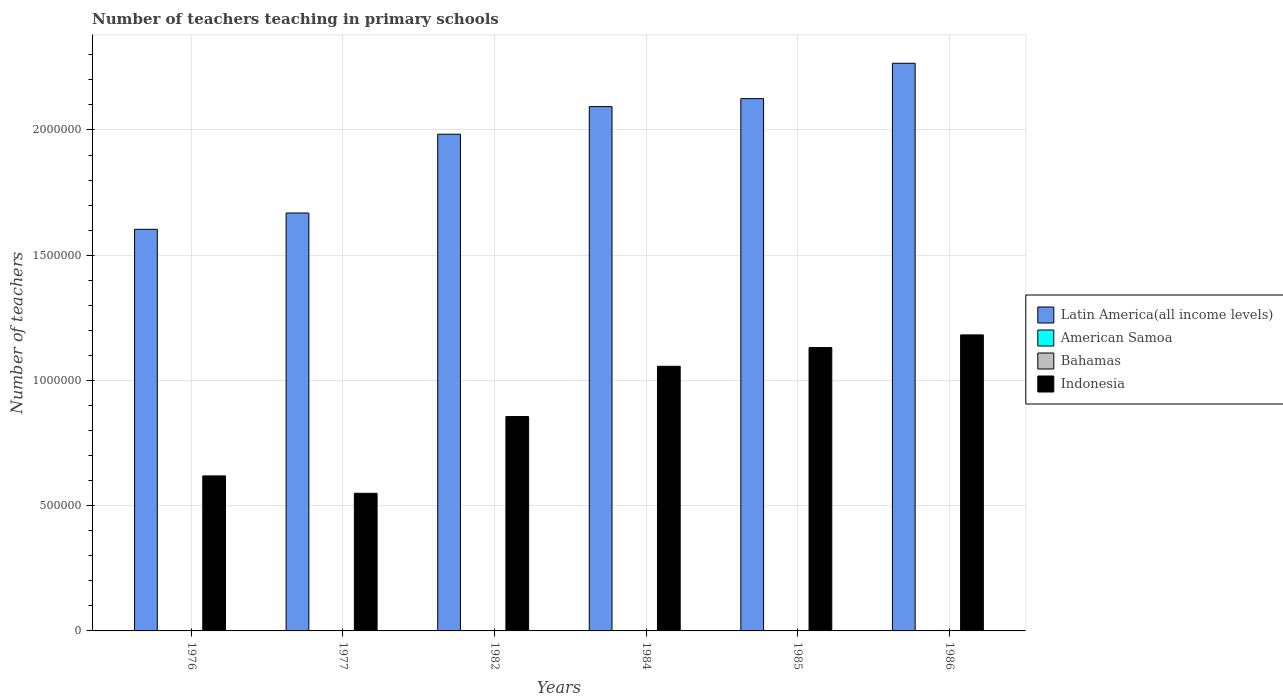How many groups of bars are there?
Offer a very short reply. 6. How many bars are there on the 6th tick from the left?
Provide a succinct answer. 4. What is the label of the 3rd group of bars from the left?
Offer a terse response. 1982. What is the number of teachers teaching in primary schools in Indonesia in 1986?
Give a very brief answer. 1.18e+06. Across all years, what is the maximum number of teachers teaching in primary schools in Indonesia?
Offer a very short reply. 1.18e+06. Across all years, what is the minimum number of teachers teaching in primary schools in Latin America(all income levels)?
Make the answer very short. 1.60e+06. In which year was the number of teachers teaching in primary schools in Latin America(all income levels) maximum?
Give a very brief answer. 1986. What is the total number of teachers teaching in primary schools in Bahamas in the graph?
Give a very brief answer. 8755. What is the difference between the number of teachers teaching in primary schools in Bahamas in 1976 and that in 1977?
Provide a short and direct response. -123. What is the difference between the number of teachers teaching in primary schools in Indonesia in 1977 and the number of teachers teaching in primary schools in American Samoa in 1985?
Make the answer very short. 5.49e+05. What is the average number of teachers teaching in primary schools in Indonesia per year?
Make the answer very short. 8.99e+05. In the year 1984, what is the difference between the number of teachers teaching in primary schools in American Samoa and number of teachers teaching in primary schools in Latin America(all income levels)?
Provide a succinct answer. -2.09e+06. In how many years, is the number of teachers teaching in primary schools in American Samoa greater than 300000?
Your answer should be very brief. 0. What is the ratio of the number of teachers teaching in primary schools in Latin America(all income levels) in 1976 to that in 1986?
Offer a terse response. 0.71. Is the number of teachers teaching in primary schools in American Samoa in 1976 less than that in 1985?
Your answer should be compact. Yes. Is the difference between the number of teachers teaching in primary schools in American Samoa in 1982 and 1986 greater than the difference between the number of teachers teaching in primary schools in Latin America(all income levels) in 1982 and 1986?
Offer a very short reply. Yes. What is the difference between the highest and the second highest number of teachers teaching in primary schools in Latin America(all income levels)?
Your answer should be compact. 1.41e+05. What is the difference between the highest and the lowest number of teachers teaching in primary schools in Indonesia?
Ensure brevity in your answer.  6.32e+05. In how many years, is the number of teachers teaching in primary schools in Latin America(all income levels) greater than the average number of teachers teaching in primary schools in Latin America(all income levels) taken over all years?
Ensure brevity in your answer.  4. Is the sum of the number of teachers teaching in primary schools in American Samoa in 1982 and 1984 greater than the maximum number of teachers teaching in primary schools in Indonesia across all years?
Provide a succinct answer. No. Is it the case that in every year, the sum of the number of teachers teaching in primary schools in Indonesia and number of teachers teaching in primary schools in American Samoa is greater than the sum of number of teachers teaching in primary schools in Bahamas and number of teachers teaching in primary schools in Latin America(all income levels)?
Give a very brief answer. No. What does the 2nd bar from the left in 1984 represents?
Provide a succinct answer. American Samoa. What does the 3rd bar from the right in 1986 represents?
Ensure brevity in your answer.  American Samoa. How many bars are there?
Offer a terse response. 24. Are all the bars in the graph horizontal?
Offer a terse response. No. How many years are there in the graph?
Keep it short and to the point. 6. Are the values on the major ticks of Y-axis written in scientific E-notation?
Offer a very short reply. No. Does the graph contain any zero values?
Keep it short and to the point. No. Does the graph contain grids?
Give a very brief answer. Yes. Where does the legend appear in the graph?
Keep it short and to the point. Center right. How many legend labels are there?
Offer a very short reply. 4. How are the legend labels stacked?
Make the answer very short. Vertical. What is the title of the graph?
Offer a terse response. Number of teachers teaching in primary schools. What is the label or title of the X-axis?
Give a very brief answer. Years. What is the label or title of the Y-axis?
Provide a short and direct response. Number of teachers. What is the Number of teachers of Latin America(all income levels) in 1976?
Offer a very short reply. 1.60e+06. What is the Number of teachers of American Samoa in 1976?
Give a very brief answer. 302. What is the Number of teachers in Bahamas in 1976?
Provide a succinct answer. 1294. What is the Number of teachers of Indonesia in 1976?
Give a very brief answer. 6.19e+05. What is the Number of teachers of Latin America(all income levels) in 1977?
Provide a succinct answer. 1.67e+06. What is the Number of teachers of American Samoa in 1977?
Offer a terse response. 310. What is the Number of teachers in Bahamas in 1977?
Offer a terse response. 1417. What is the Number of teachers of Indonesia in 1977?
Your response must be concise. 5.50e+05. What is the Number of teachers in Latin America(all income levels) in 1982?
Your answer should be compact. 1.98e+06. What is the Number of teachers in American Samoa in 1982?
Ensure brevity in your answer.  395. What is the Number of teachers in Bahamas in 1982?
Ensure brevity in your answer.  1151. What is the Number of teachers of Indonesia in 1982?
Offer a terse response. 8.56e+05. What is the Number of teachers of Latin America(all income levels) in 1984?
Offer a terse response. 2.09e+06. What is the Number of teachers of American Samoa in 1984?
Your response must be concise. 346. What is the Number of teachers of Bahamas in 1984?
Your response must be concise. 1565. What is the Number of teachers in Indonesia in 1984?
Ensure brevity in your answer.  1.06e+06. What is the Number of teachers in Latin America(all income levels) in 1985?
Your answer should be very brief. 2.13e+06. What is the Number of teachers of American Samoa in 1985?
Provide a succinct answer. 359. What is the Number of teachers in Bahamas in 1985?
Provide a succinct answer. 1561. What is the Number of teachers in Indonesia in 1985?
Your answer should be very brief. 1.13e+06. What is the Number of teachers in Latin America(all income levels) in 1986?
Make the answer very short. 2.27e+06. What is the Number of teachers of American Samoa in 1986?
Give a very brief answer. 454. What is the Number of teachers of Bahamas in 1986?
Keep it short and to the point. 1767. What is the Number of teachers in Indonesia in 1986?
Provide a succinct answer. 1.18e+06. Across all years, what is the maximum Number of teachers in Latin America(all income levels)?
Offer a very short reply. 2.27e+06. Across all years, what is the maximum Number of teachers of American Samoa?
Make the answer very short. 454. Across all years, what is the maximum Number of teachers in Bahamas?
Keep it short and to the point. 1767. Across all years, what is the maximum Number of teachers in Indonesia?
Offer a very short reply. 1.18e+06. Across all years, what is the minimum Number of teachers of Latin America(all income levels)?
Your answer should be very brief. 1.60e+06. Across all years, what is the minimum Number of teachers of American Samoa?
Your answer should be very brief. 302. Across all years, what is the minimum Number of teachers of Bahamas?
Make the answer very short. 1151. Across all years, what is the minimum Number of teachers of Indonesia?
Your response must be concise. 5.50e+05. What is the total Number of teachers in Latin America(all income levels) in the graph?
Offer a very short reply. 1.17e+07. What is the total Number of teachers in American Samoa in the graph?
Ensure brevity in your answer.  2166. What is the total Number of teachers in Bahamas in the graph?
Offer a terse response. 8755. What is the total Number of teachers in Indonesia in the graph?
Your answer should be very brief. 5.39e+06. What is the difference between the Number of teachers in Latin America(all income levels) in 1976 and that in 1977?
Your response must be concise. -6.51e+04. What is the difference between the Number of teachers in American Samoa in 1976 and that in 1977?
Give a very brief answer. -8. What is the difference between the Number of teachers of Bahamas in 1976 and that in 1977?
Provide a succinct answer. -123. What is the difference between the Number of teachers in Indonesia in 1976 and that in 1977?
Offer a very short reply. 6.93e+04. What is the difference between the Number of teachers of Latin America(all income levels) in 1976 and that in 1982?
Offer a very short reply. -3.80e+05. What is the difference between the Number of teachers of American Samoa in 1976 and that in 1982?
Your answer should be compact. -93. What is the difference between the Number of teachers of Bahamas in 1976 and that in 1982?
Ensure brevity in your answer.  143. What is the difference between the Number of teachers of Indonesia in 1976 and that in 1982?
Offer a very short reply. -2.37e+05. What is the difference between the Number of teachers in Latin America(all income levels) in 1976 and that in 1984?
Give a very brief answer. -4.90e+05. What is the difference between the Number of teachers in American Samoa in 1976 and that in 1984?
Provide a short and direct response. -44. What is the difference between the Number of teachers of Bahamas in 1976 and that in 1984?
Give a very brief answer. -271. What is the difference between the Number of teachers in Indonesia in 1976 and that in 1984?
Keep it short and to the point. -4.38e+05. What is the difference between the Number of teachers of Latin America(all income levels) in 1976 and that in 1985?
Give a very brief answer. -5.22e+05. What is the difference between the Number of teachers in American Samoa in 1976 and that in 1985?
Your answer should be very brief. -57. What is the difference between the Number of teachers of Bahamas in 1976 and that in 1985?
Ensure brevity in your answer.  -267. What is the difference between the Number of teachers in Indonesia in 1976 and that in 1985?
Give a very brief answer. -5.12e+05. What is the difference between the Number of teachers of Latin America(all income levels) in 1976 and that in 1986?
Keep it short and to the point. -6.63e+05. What is the difference between the Number of teachers of American Samoa in 1976 and that in 1986?
Ensure brevity in your answer.  -152. What is the difference between the Number of teachers in Bahamas in 1976 and that in 1986?
Make the answer very short. -473. What is the difference between the Number of teachers in Indonesia in 1976 and that in 1986?
Provide a short and direct response. -5.63e+05. What is the difference between the Number of teachers in Latin America(all income levels) in 1977 and that in 1982?
Your answer should be compact. -3.15e+05. What is the difference between the Number of teachers of American Samoa in 1977 and that in 1982?
Offer a terse response. -85. What is the difference between the Number of teachers of Bahamas in 1977 and that in 1982?
Keep it short and to the point. 266. What is the difference between the Number of teachers of Indonesia in 1977 and that in 1982?
Provide a short and direct response. -3.06e+05. What is the difference between the Number of teachers in Latin America(all income levels) in 1977 and that in 1984?
Ensure brevity in your answer.  -4.25e+05. What is the difference between the Number of teachers of American Samoa in 1977 and that in 1984?
Keep it short and to the point. -36. What is the difference between the Number of teachers of Bahamas in 1977 and that in 1984?
Ensure brevity in your answer.  -148. What is the difference between the Number of teachers in Indonesia in 1977 and that in 1984?
Provide a succinct answer. -5.07e+05. What is the difference between the Number of teachers in Latin America(all income levels) in 1977 and that in 1985?
Give a very brief answer. -4.57e+05. What is the difference between the Number of teachers of American Samoa in 1977 and that in 1985?
Provide a short and direct response. -49. What is the difference between the Number of teachers of Bahamas in 1977 and that in 1985?
Ensure brevity in your answer.  -144. What is the difference between the Number of teachers of Indonesia in 1977 and that in 1985?
Provide a succinct answer. -5.82e+05. What is the difference between the Number of teachers of Latin America(all income levels) in 1977 and that in 1986?
Ensure brevity in your answer.  -5.98e+05. What is the difference between the Number of teachers in American Samoa in 1977 and that in 1986?
Offer a very short reply. -144. What is the difference between the Number of teachers in Bahamas in 1977 and that in 1986?
Offer a terse response. -350. What is the difference between the Number of teachers in Indonesia in 1977 and that in 1986?
Ensure brevity in your answer.  -6.32e+05. What is the difference between the Number of teachers of Latin America(all income levels) in 1982 and that in 1984?
Offer a terse response. -1.10e+05. What is the difference between the Number of teachers of Bahamas in 1982 and that in 1984?
Offer a very short reply. -414. What is the difference between the Number of teachers of Indonesia in 1982 and that in 1984?
Offer a very short reply. -2.01e+05. What is the difference between the Number of teachers of Latin America(all income levels) in 1982 and that in 1985?
Provide a succinct answer. -1.42e+05. What is the difference between the Number of teachers of Bahamas in 1982 and that in 1985?
Give a very brief answer. -410. What is the difference between the Number of teachers in Indonesia in 1982 and that in 1985?
Provide a succinct answer. -2.75e+05. What is the difference between the Number of teachers of Latin America(all income levels) in 1982 and that in 1986?
Offer a very short reply. -2.83e+05. What is the difference between the Number of teachers in American Samoa in 1982 and that in 1986?
Keep it short and to the point. -59. What is the difference between the Number of teachers in Bahamas in 1982 and that in 1986?
Offer a terse response. -616. What is the difference between the Number of teachers of Indonesia in 1982 and that in 1986?
Offer a very short reply. -3.26e+05. What is the difference between the Number of teachers in Latin America(all income levels) in 1984 and that in 1985?
Offer a terse response. -3.20e+04. What is the difference between the Number of teachers in American Samoa in 1984 and that in 1985?
Offer a very short reply. -13. What is the difference between the Number of teachers of Indonesia in 1984 and that in 1985?
Provide a succinct answer. -7.48e+04. What is the difference between the Number of teachers in Latin America(all income levels) in 1984 and that in 1986?
Provide a short and direct response. -1.73e+05. What is the difference between the Number of teachers in American Samoa in 1984 and that in 1986?
Give a very brief answer. -108. What is the difference between the Number of teachers in Bahamas in 1984 and that in 1986?
Make the answer very short. -202. What is the difference between the Number of teachers of Indonesia in 1984 and that in 1986?
Your response must be concise. -1.25e+05. What is the difference between the Number of teachers of Latin America(all income levels) in 1985 and that in 1986?
Keep it short and to the point. -1.41e+05. What is the difference between the Number of teachers of American Samoa in 1985 and that in 1986?
Your answer should be very brief. -95. What is the difference between the Number of teachers in Bahamas in 1985 and that in 1986?
Your response must be concise. -206. What is the difference between the Number of teachers in Indonesia in 1985 and that in 1986?
Provide a short and direct response. -5.05e+04. What is the difference between the Number of teachers in Latin America(all income levels) in 1976 and the Number of teachers in American Samoa in 1977?
Ensure brevity in your answer.  1.60e+06. What is the difference between the Number of teachers of Latin America(all income levels) in 1976 and the Number of teachers of Bahamas in 1977?
Make the answer very short. 1.60e+06. What is the difference between the Number of teachers in Latin America(all income levels) in 1976 and the Number of teachers in Indonesia in 1977?
Make the answer very short. 1.05e+06. What is the difference between the Number of teachers of American Samoa in 1976 and the Number of teachers of Bahamas in 1977?
Give a very brief answer. -1115. What is the difference between the Number of teachers of American Samoa in 1976 and the Number of teachers of Indonesia in 1977?
Offer a very short reply. -5.49e+05. What is the difference between the Number of teachers of Bahamas in 1976 and the Number of teachers of Indonesia in 1977?
Your response must be concise. -5.48e+05. What is the difference between the Number of teachers in Latin America(all income levels) in 1976 and the Number of teachers in American Samoa in 1982?
Make the answer very short. 1.60e+06. What is the difference between the Number of teachers in Latin America(all income levels) in 1976 and the Number of teachers in Bahamas in 1982?
Make the answer very short. 1.60e+06. What is the difference between the Number of teachers in Latin America(all income levels) in 1976 and the Number of teachers in Indonesia in 1982?
Ensure brevity in your answer.  7.47e+05. What is the difference between the Number of teachers of American Samoa in 1976 and the Number of teachers of Bahamas in 1982?
Your response must be concise. -849. What is the difference between the Number of teachers in American Samoa in 1976 and the Number of teachers in Indonesia in 1982?
Your answer should be very brief. -8.56e+05. What is the difference between the Number of teachers in Bahamas in 1976 and the Number of teachers in Indonesia in 1982?
Your response must be concise. -8.55e+05. What is the difference between the Number of teachers of Latin America(all income levels) in 1976 and the Number of teachers of American Samoa in 1984?
Offer a terse response. 1.60e+06. What is the difference between the Number of teachers of Latin America(all income levels) in 1976 and the Number of teachers of Bahamas in 1984?
Offer a terse response. 1.60e+06. What is the difference between the Number of teachers in Latin America(all income levels) in 1976 and the Number of teachers in Indonesia in 1984?
Your response must be concise. 5.47e+05. What is the difference between the Number of teachers in American Samoa in 1976 and the Number of teachers in Bahamas in 1984?
Make the answer very short. -1263. What is the difference between the Number of teachers in American Samoa in 1976 and the Number of teachers in Indonesia in 1984?
Your answer should be compact. -1.06e+06. What is the difference between the Number of teachers in Bahamas in 1976 and the Number of teachers in Indonesia in 1984?
Give a very brief answer. -1.06e+06. What is the difference between the Number of teachers in Latin America(all income levels) in 1976 and the Number of teachers in American Samoa in 1985?
Offer a terse response. 1.60e+06. What is the difference between the Number of teachers of Latin America(all income levels) in 1976 and the Number of teachers of Bahamas in 1985?
Your answer should be very brief. 1.60e+06. What is the difference between the Number of teachers in Latin America(all income levels) in 1976 and the Number of teachers in Indonesia in 1985?
Provide a short and direct response. 4.72e+05. What is the difference between the Number of teachers in American Samoa in 1976 and the Number of teachers in Bahamas in 1985?
Your answer should be very brief. -1259. What is the difference between the Number of teachers of American Samoa in 1976 and the Number of teachers of Indonesia in 1985?
Provide a succinct answer. -1.13e+06. What is the difference between the Number of teachers in Bahamas in 1976 and the Number of teachers in Indonesia in 1985?
Ensure brevity in your answer.  -1.13e+06. What is the difference between the Number of teachers of Latin America(all income levels) in 1976 and the Number of teachers of American Samoa in 1986?
Give a very brief answer. 1.60e+06. What is the difference between the Number of teachers of Latin America(all income levels) in 1976 and the Number of teachers of Bahamas in 1986?
Your response must be concise. 1.60e+06. What is the difference between the Number of teachers in Latin America(all income levels) in 1976 and the Number of teachers in Indonesia in 1986?
Provide a short and direct response. 4.22e+05. What is the difference between the Number of teachers in American Samoa in 1976 and the Number of teachers in Bahamas in 1986?
Provide a succinct answer. -1465. What is the difference between the Number of teachers of American Samoa in 1976 and the Number of teachers of Indonesia in 1986?
Your answer should be very brief. -1.18e+06. What is the difference between the Number of teachers of Bahamas in 1976 and the Number of teachers of Indonesia in 1986?
Your answer should be very brief. -1.18e+06. What is the difference between the Number of teachers in Latin America(all income levels) in 1977 and the Number of teachers in American Samoa in 1982?
Your response must be concise. 1.67e+06. What is the difference between the Number of teachers of Latin America(all income levels) in 1977 and the Number of teachers of Bahamas in 1982?
Your response must be concise. 1.67e+06. What is the difference between the Number of teachers in Latin America(all income levels) in 1977 and the Number of teachers in Indonesia in 1982?
Provide a short and direct response. 8.13e+05. What is the difference between the Number of teachers of American Samoa in 1977 and the Number of teachers of Bahamas in 1982?
Ensure brevity in your answer.  -841. What is the difference between the Number of teachers in American Samoa in 1977 and the Number of teachers in Indonesia in 1982?
Give a very brief answer. -8.56e+05. What is the difference between the Number of teachers of Bahamas in 1977 and the Number of teachers of Indonesia in 1982?
Provide a short and direct response. -8.54e+05. What is the difference between the Number of teachers in Latin America(all income levels) in 1977 and the Number of teachers in American Samoa in 1984?
Provide a short and direct response. 1.67e+06. What is the difference between the Number of teachers of Latin America(all income levels) in 1977 and the Number of teachers of Bahamas in 1984?
Your answer should be very brief. 1.67e+06. What is the difference between the Number of teachers in Latin America(all income levels) in 1977 and the Number of teachers in Indonesia in 1984?
Your response must be concise. 6.12e+05. What is the difference between the Number of teachers in American Samoa in 1977 and the Number of teachers in Bahamas in 1984?
Offer a very short reply. -1255. What is the difference between the Number of teachers in American Samoa in 1977 and the Number of teachers in Indonesia in 1984?
Keep it short and to the point. -1.06e+06. What is the difference between the Number of teachers in Bahamas in 1977 and the Number of teachers in Indonesia in 1984?
Offer a terse response. -1.06e+06. What is the difference between the Number of teachers in Latin America(all income levels) in 1977 and the Number of teachers in American Samoa in 1985?
Provide a short and direct response. 1.67e+06. What is the difference between the Number of teachers in Latin America(all income levels) in 1977 and the Number of teachers in Bahamas in 1985?
Your answer should be compact. 1.67e+06. What is the difference between the Number of teachers of Latin America(all income levels) in 1977 and the Number of teachers of Indonesia in 1985?
Keep it short and to the point. 5.37e+05. What is the difference between the Number of teachers of American Samoa in 1977 and the Number of teachers of Bahamas in 1985?
Keep it short and to the point. -1251. What is the difference between the Number of teachers in American Samoa in 1977 and the Number of teachers in Indonesia in 1985?
Make the answer very short. -1.13e+06. What is the difference between the Number of teachers in Bahamas in 1977 and the Number of teachers in Indonesia in 1985?
Your answer should be compact. -1.13e+06. What is the difference between the Number of teachers of Latin America(all income levels) in 1977 and the Number of teachers of American Samoa in 1986?
Your answer should be compact. 1.67e+06. What is the difference between the Number of teachers of Latin America(all income levels) in 1977 and the Number of teachers of Bahamas in 1986?
Offer a very short reply. 1.67e+06. What is the difference between the Number of teachers of Latin America(all income levels) in 1977 and the Number of teachers of Indonesia in 1986?
Your answer should be compact. 4.87e+05. What is the difference between the Number of teachers in American Samoa in 1977 and the Number of teachers in Bahamas in 1986?
Ensure brevity in your answer.  -1457. What is the difference between the Number of teachers in American Samoa in 1977 and the Number of teachers in Indonesia in 1986?
Provide a short and direct response. -1.18e+06. What is the difference between the Number of teachers in Bahamas in 1977 and the Number of teachers in Indonesia in 1986?
Ensure brevity in your answer.  -1.18e+06. What is the difference between the Number of teachers in Latin America(all income levels) in 1982 and the Number of teachers in American Samoa in 1984?
Your answer should be compact. 1.98e+06. What is the difference between the Number of teachers of Latin America(all income levels) in 1982 and the Number of teachers of Bahamas in 1984?
Offer a very short reply. 1.98e+06. What is the difference between the Number of teachers of Latin America(all income levels) in 1982 and the Number of teachers of Indonesia in 1984?
Provide a short and direct response. 9.27e+05. What is the difference between the Number of teachers of American Samoa in 1982 and the Number of teachers of Bahamas in 1984?
Provide a short and direct response. -1170. What is the difference between the Number of teachers of American Samoa in 1982 and the Number of teachers of Indonesia in 1984?
Your answer should be very brief. -1.06e+06. What is the difference between the Number of teachers in Bahamas in 1982 and the Number of teachers in Indonesia in 1984?
Give a very brief answer. -1.06e+06. What is the difference between the Number of teachers of Latin America(all income levels) in 1982 and the Number of teachers of American Samoa in 1985?
Offer a terse response. 1.98e+06. What is the difference between the Number of teachers of Latin America(all income levels) in 1982 and the Number of teachers of Bahamas in 1985?
Ensure brevity in your answer.  1.98e+06. What is the difference between the Number of teachers in Latin America(all income levels) in 1982 and the Number of teachers in Indonesia in 1985?
Offer a very short reply. 8.52e+05. What is the difference between the Number of teachers of American Samoa in 1982 and the Number of teachers of Bahamas in 1985?
Keep it short and to the point. -1166. What is the difference between the Number of teachers in American Samoa in 1982 and the Number of teachers in Indonesia in 1985?
Your answer should be compact. -1.13e+06. What is the difference between the Number of teachers in Bahamas in 1982 and the Number of teachers in Indonesia in 1985?
Keep it short and to the point. -1.13e+06. What is the difference between the Number of teachers of Latin America(all income levels) in 1982 and the Number of teachers of American Samoa in 1986?
Ensure brevity in your answer.  1.98e+06. What is the difference between the Number of teachers of Latin America(all income levels) in 1982 and the Number of teachers of Bahamas in 1986?
Ensure brevity in your answer.  1.98e+06. What is the difference between the Number of teachers of Latin America(all income levels) in 1982 and the Number of teachers of Indonesia in 1986?
Keep it short and to the point. 8.01e+05. What is the difference between the Number of teachers in American Samoa in 1982 and the Number of teachers in Bahamas in 1986?
Provide a succinct answer. -1372. What is the difference between the Number of teachers in American Samoa in 1982 and the Number of teachers in Indonesia in 1986?
Your answer should be compact. -1.18e+06. What is the difference between the Number of teachers of Bahamas in 1982 and the Number of teachers of Indonesia in 1986?
Provide a short and direct response. -1.18e+06. What is the difference between the Number of teachers in Latin America(all income levels) in 1984 and the Number of teachers in American Samoa in 1985?
Offer a very short reply. 2.09e+06. What is the difference between the Number of teachers in Latin America(all income levels) in 1984 and the Number of teachers in Bahamas in 1985?
Provide a short and direct response. 2.09e+06. What is the difference between the Number of teachers in Latin America(all income levels) in 1984 and the Number of teachers in Indonesia in 1985?
Offer a very short reply. 9.62e+05. What is the difference between the Number of teachers in American Samoa in 1984 and the Number of teachers in Bahamas in 1985?
Your answer should be compact. -1215. What is the difference between the Number of teachers of American Samoa in 1984 and the Number of teachers of Indonesia in 1985?
Offer a terse response. -1.13e+06. What is the difference between the Number of teachers in Bahamas in 1984 and the Number of teachers in Indonesia in 1985?
Ensure brevity in your answer.  -1.13e+06. What is the difference between the Number of teachers in Latin America(all income levels) in 1984 and the Number of teachers in American Samoa in 1986?
Your answer should be very brief. 2.09e+06. What is the difference between the Number of teachers in Latin America(all income levels) in 1984 and the Number of teachers in Bahamas in 1986?
Your answer should be compact. 2.09e+06. What is the difference between the Number of teachers in Latin America(all income levels) in 1984 and the Number of teachers in Indonesia in 1986?
Give a very brief answer. 9.11e+05. What is the difference between the Number of teachers of American Samoa in 1984 and the Number of teachers of Bahamas in 1986?
Ensure brevity in your answer.  -1421. What is the difference between the Number of teachers of American Samoa in 1984 and the Number of teachers of Indonesia in 1986?
Your answer should be compact. -1.18e+06. What is the difference between the Number of teachers in Bahamas in 1984 and the Number of teachers in Indonesia in 1986?
Give a very brief answer. -1.18e+06. What is the difference between the Number of teachers of Latin America(all income levels) in 1985 and the Number of teachers of American Samoa in 1986?
Provide a succinct answer. 2.12e+06. What is the difference between the Number of teachers of Latin America(all income levels) in 1985 and the Number of teachers of Bahamas in 1986?
Offer a terse response. 2.12e+06. What is the difference between the Number of teachers of Latin America(all income levels) in 1985 and the Number of teachers of Indonesia in 1986?
Give a very brief answer. 9.43e+05. What is the difference between the Number of teachers of American Samoa in 1985 and the Number of teachers of Bahamas in 1986?
Your answer should be compact. -1408. What is the difference between the Number of teachers of American Samoa in 1985 and the Number of teachers of Indonesia in 1986?
Provide a succinct answer. -1.18e+06. What is the difference between the Number of teachers in Bahamas in 1985 and the Number of teachers in Indonesia in 1986?
Provide a short and direct response. -1.18e+06. What is the average Number of teachers of Latin America(all income levels) per year?
Offer a terse response. 1.96e+06. What is the average Number of teachers in American Samoa per year?
Give a very brief answer. 361. What is the average Number of teachers in Bahamas per year?
Your answer should be very brief. 1459.17. What is the average Number of teachers in Indonesia per year?
Provide a short and direct response. 8.99e+05. In the year 1976, what is the difference between the Number of teachers of Latin America(all income levels) and Number of teachers of American Samoa?
Your answer should be very brief. 1.60e+06. In the year 1976, what is the difference between the Number of teachers of Latin America(all income levels) and Number of teachers of Bahamas?
Your answer should be very brief. 1.60e+06. In the year 1976, what is the difference between the Number of teachers in Latin America(all income levels) and Number of teachers in Indonesia?
Your response must be concise. 9.85e+05. In the year 1976, what is the difference between the Number of teachers of American Samoa and Number of teachers of Bahamas?
Your answer should be very brief. -992. In the year 1976, what is the difference between the Number of teachers of American Samoa and Number of teachers of Indonesia?
Your response must be concise. -6.19e+05. In the year 1976, what is the difference between the Number of teachers in Bahamas and Number of teachers in Indonesia?
Your answer should be compact. -6.18e+05. In the year 1977, what is the difference between the Number of teachers in Latin America(all income levels) and Number of teachers in American Samoa?
Provide a short and direct response. 1.67e+06. In the year 1977, what is the difference between the Number of teachers of Latin America(all income levels) and Number of teachers of Bahamas?
Offer a terse response. 1.67e+06. In the year 1977, what is the difference between the Number of teachers of Latin America(all income levels) and Number of teachers of Indonesia?
Your response must be concise. 1.12e+06. In the year 1977, what is the difference between the Number of teachers in American Samoa and Number of teachers in Bahamas?
Your response must be concise. -1107. In the year 1977, what is the difference between the Number of teachers in American Samoa and Number of teachers in Indonesia?
Provide a succinct answer. -5.49e+05. In the year 1977, what is the difference between the Number of teachers in Bahamas and Number of teachers in Indonesia?
Your response must be concise. -5.48e+05. In the year 1982, what is the difference between the Number of teachers of Latin America(all income levels) and Number of teachers of American Samoa?
Give a very brief answer. 1.98e+06. In the year 1982, what is the difference between the Number of teachers in Latin America(all income levels) and Number of teachers in Bahamas?
Give a very brief answer. 1.98e+06. In the year 1982, what is the difference between the Number of teachers in Latin America(all income levels) and Number of teachers in Indonesia?
Keep it short and to the point. 1.13e+06. In the year 1982, what is the difference between the Number of teachers of American Samoa and Number of teachers of Bahamas?
Offer a terse response. -756. In the year 1982, what is the difference between the Number of teachers of American Samoa and Number of teachers of Indonesia?
Make the answer very short. -8.55e+05. In the year 1982, what is the difference between the Number of teachers in Bahamas and Number of teachers in Indonesia?
Your answer should be very brief. -8.55e+05. In the year 1984, what is the difference between the Number of teachers of Latin America(all income levels) and Number of teachers of American Samoa?
Give a very brief answer. 2.09e+06. In the year 1984, what is the difference between the Number of teachers in Latin America(all income levels) and Number of teachers in Bahamas?
Give a very brief answer. 2.09e+06. In the year 1984, what is the difference between the Number of teachers of Latin America(all income levels) and Number of teachers of Indonesia?
Offer a terse response. 1.04e+06. In the year 1984, what is the difference between the Number of teachers in American Samoa and Number of teachers in Bahamas?
Ensure brevity in your answer.  -1219. In the year 1984, what is the difference between the Number of teachers of American Samoa and Number of teachers of Indonesia?
Ensure brevity in your answer.  -1.06e+06. In the year 1984, what is the difference between the Number of teachers in Bahamas and Number of teachers in Indonesia?
Offer a very short reply. -1.05e+06. In the year 1985, what is the difference between the Number of teachers of Latin America(all income levels) and Number of teachers of American Samoa?
Provide a short and direct response. 2.12e+06. In the year 1985, what is the difference between the Number of teachers of Latin America(all income levels) and Number of teachers of Bahamas?
Give a very brief answer. 2.12e+06. In the year 1985, what is the difference between the Number of teachers of Latin America(all income levels) and Number of teachers of Indonesia?
Keep it short and to the point. 9.94e+05. In the year 1985, what is the difference between the Number of teachers in American Samoa and Number of teachers in Bahamas?
Provide a succinct answer. -1202. In the year 1985, what is the difference between the Number of teachers in American Samoa and Number of teachers in Indonesia?
Keep it short and to the point. -1.13e+06. In the year 1985, what is the difference between the Number of teachers in Bahamas and Number of teachers in Indonesia?
Make the answer very short. -1.13e+06. In the year 1986, what is the difference between the Number of teachers in Latin America(all income levels) and Number of teachers in American Samoa?
Provide a succinct answer. 2.27e+06. In the year 1986, what is the difference between the Number of teachers in Latin America(all income levels) and Number of teachers in Bahamas?
Your response must be concise. 2.26e+06. In the year 1986, what is the difference between the Number of teachers of Latin America(all income levels) and Number of teachers of Indonesia?
Ensure brevity in your answer.  1.08e+06. In the year 1986, what is the difference between the Number of teachers in American Samoa and Number of teachers in Bahamas?
Make the answer very short. -1313. In the year 1986, what is the difference between the Number of teachers of American Samoa and Number of teachers of Indonesia?
Ensure brevity in your answer.  -1.18e+06. In the year 1986, what is the difference between the Number of teachers in Bahamas and Number of teachers in Indonesia?
Ensure brevity in your answer.  -1.18e+06. What is the ratio of the Number of teachers of American Samoa in 1976 to that in 1977?
Keep it short and to the point. 0.97. What is the ratio of the Number of teachers in Bahamas in 1976 to that in 1977?
Give a very brief answer. 0.91. What is the ratio of the Number of teachers of Indonesia in 1976 to that in 1977?
Offer a very short reply. 1.13. What is the ratio of the Number of teachers of Latin America(all income levels) in 1976 to that in 1982?
Your answer should be compact. 0.81. What is the ratio of the Number of teachers of American Samoa in 1976 to that in 1982?
Provide a short and direct response. 0.76. What is the ratio of the Number of teachers of Bahamas in 1976 to that in 1982?
Provide a short and direct response. 1.12. What is the ratio of the Number of teachers in Indonesia in 1976 to that in 1982?
Provide a short and direct response. 0.72. What is the ratio of the Number of teachers of Latin America(all income levels) in 1976 to that in 1984?
Your answer should be compact. 0.77. What is the ratio of the Number of teachers in American Samoa in 1976 to that in 1984?
Provide a short and direct response. 0.87. What is the ratio of the Number of teachers of Bahamas in 1976 to that in 1984?
Make the answer very short. 0.83. What is the ratio of the Number of teachers of Indonesia in 1976 to that in 1984?
Your answer should be very brief. 0.59. What is the ratio of the Number of teachers of Latin America(all income levels) in 1976 to that in 1985?
Make the answer very short. 0.75. What is the ratio of the Number of teachers in American Samoa in 1976 to that in 1985?
Ensure brevity in your answer.  0.84. What is the ratio of the Number of teachers of Bahamas in 1976 to that in 1985?
Keep it short and to the point. 0.83. What is the ratio of the Number of teachers in Indonesia in 1976 to that in 1985?
Ensure brevity in your answer.  0.55. What is the ratio of the Number of teachers in Latin America(all income levels) in 1976 to that in 1986?
Keep it short and to the point. 0.71. What is the ratio of the Number of teachers of American Samoa in 1976 to that in 1986?
Your answer should be compact. 0.67. What is the ratio of the Number of teachers in Bahamas in 1976 to that in 1986?
Make the answer very short. 0.73. What is the ratio of the Number of teachers of Indonesia in 1976 to that in 1986?
Offer a terse response. 0.52. What is the ratio of the Number of teachers of Latin America(all income levels) in 1977 to that in 1982?
Offer a terse response. 0.84. What is the ratio of the Number of teachers in American Samoa in 1977 to that in 1982?
Ensure brevity in your answer.  0.78. What is the ratio of the Number of teachers of Bahamas in 1977 to that in 1982?
Keep it short and to the point. 1.23. What is the ratio of the Number of teachers in Indonesia in 1977 to that in 1982?
Give a very brief answer. 0.64. What is the ratio of the Number of teachers in Latin America(all income levels) in 1977 to that in 1984?
Keep it short and to the point. 0.8. What is the ratio of the Number of teachers of American Samoa in 1977 to that in 1984?
Provide a succinct answer. 0.9. What is the ratio of the Number of teachers in Bahamas in 1977 to that in 1984?
Keep it short and to the point. 0.91. What is the ratio of the Number of teachers in Indonesia in 1977 to that in 1984?
Provide a succinct answer. 0.52. What is the ratio of the Number of teachers in Latin America(all income levels) in 1977 to that in 1985?
Ensure brevity in your answer.  0.79. What is the ratio of the Number of teachers in American Samoa in 1977 to that in 1985?
Your answer should be very brief. 0.86. What is the ratio of the Number of teachers of Bahamas in 1977 to that in 1985?
Provide a succinct answer. 0.91. What is the ratio of the Number of teachers of Indonesia in 1977 to that in 1985?
Your answer should be very brief. 0.49. What is the ratio of the Number of teachers in Latin America(all income levels) in 1977 to that in 1986?
Your response must be concise. 0.74. What is the ratio of the Number of teachers of American Samoa in 1977 to that in 1986?
Give a very brief answer. 0.68. What is the ratio of the Number of teachers of Bahamas in 1977 to that in 1986?
Give a very brief answer. 0.8. What is the ratio of the Number of teachers of Indonesia in 1977 to that in 1986?
Give a very brief answer. 0.47. What is the ratio of the Number of teachers in Latin America(all income levels) in 1982 to that in 1984?
Your response must be concise. 0.95. What is the ratio of the Number of teachers of American Samoa in 1982 to that in 1984?
Your answer should be very brief. 1.14. What is the ratio of the Number of teachers of Bahamas in 1982 to that in 1984?
Ensure brevity in your answer.  0.74. What is the ratio of the Number of teachers of Indonesia in 1982 to that in 1984?
Make the answer very short. 0.81. What is the ratio of the Number of teachers in Latin America(all income levels) in 1982 to that in 1985?
Give a very brief answer. 0.93. What is the ratio of the Number of teachers in American Samoa in 1982 to that in 1985?
Ensure brevity in your answer.  1.1. What is the ratio of the Number of teachers in Bahamas in 1982 to that in 1985?
Keep it short and to the point. 0.74. What is the ratio of the Number of teachers of Indonesia in 1982 to that in 1985?
Offer a very short reply. 0.76. What is the ratio of the Number of teachers in American Samoa in 1982 to that in 1986?
Offer a terse response. 0.87. What is the ratio of the Number of teachers in Bahamas in 1982 to that in 1986?
Provide a short and direct response. 0.65. What is the ratio of the Number of teachers in Indonesia in 1982 to that in 1986?
Keep it short and to the point. 0.72. What is the ratio of the Number of teachers in Latin America(all income levels) in 1984 to that in 1985?
Your answer should be compact. 0.98. What is the ratio of the Number of teachers in American Samoa in 1984 to that in 1985?
Your answer should be very brief. 0.96. What is the ratio of the Number of teachers in Bahamas in 1984 to that in 1985?
Make the answer very short. 1. What is the ratio of the Number of teachers of Indonesia in 1984 to that in 1985?
Your answer should be very brief. 0.93. What is the ratio of the Number of teachers of Latin America(all income levels) in 1984 to that in 1986?
Offer a very short reply. 0.92. What is the ratio of the Number of teachers of American Samoa in 1984 to that in 1986?
Give a very brief answer. 0.76. What is the ratio of the Number of teachers in Bahamas in 1984 to that in 1986?
Ensure brevity in your answer.  0.89. What is the ratio of the Number of teachers of Indonesia in 1984 to that in 1986?
Your response must be concise. 0.89. What is the ratio of the Number of teachers of Latin America(all income levels) in 1985 to that in 1986?
Your response must be concise. 0.94. What is the ratio of the Number of teachers in American Samoa in 1985 to that in 1986?
Provide a succinct answer. 0.79. What is the ratio of the Number of teachers of Bahamas in 1985 to that in 1986?
Keep it short and to the point. 0.88. What is the ratio of the Number of teachers in Indonesia in 1985 to that in 1986?
Provide a short and direct response. 0.96. What is the difference between the highest and the second highest Number of teachers in Latin America(all income levels)?
Your answer should be very brief. 1.41e+05. What is the difference between the highest and the second highest Number of teachers of Bahamas?
Offer a terse response. 202. What is the difference between the highest and the second highest Number of teachers in Indonesia?
Offer a very short reply. 5.05e+04. What is the difference between the highest and the lowest Number of teachers in Latin America(all income levels)?
Make the answer very short. 6.63e+05. What is the difference between the highest and the lowest Number of teachers in American Samoa?
Offer a very short reply. 152. What is the difference between the highest and the lowest Number of teachers in Bahamas?
Your answer should be very brief. 616. What is the difference between the highest and the lowest Number of teachers in Indonesia?
Make the answer very short. 6.32e+05. 